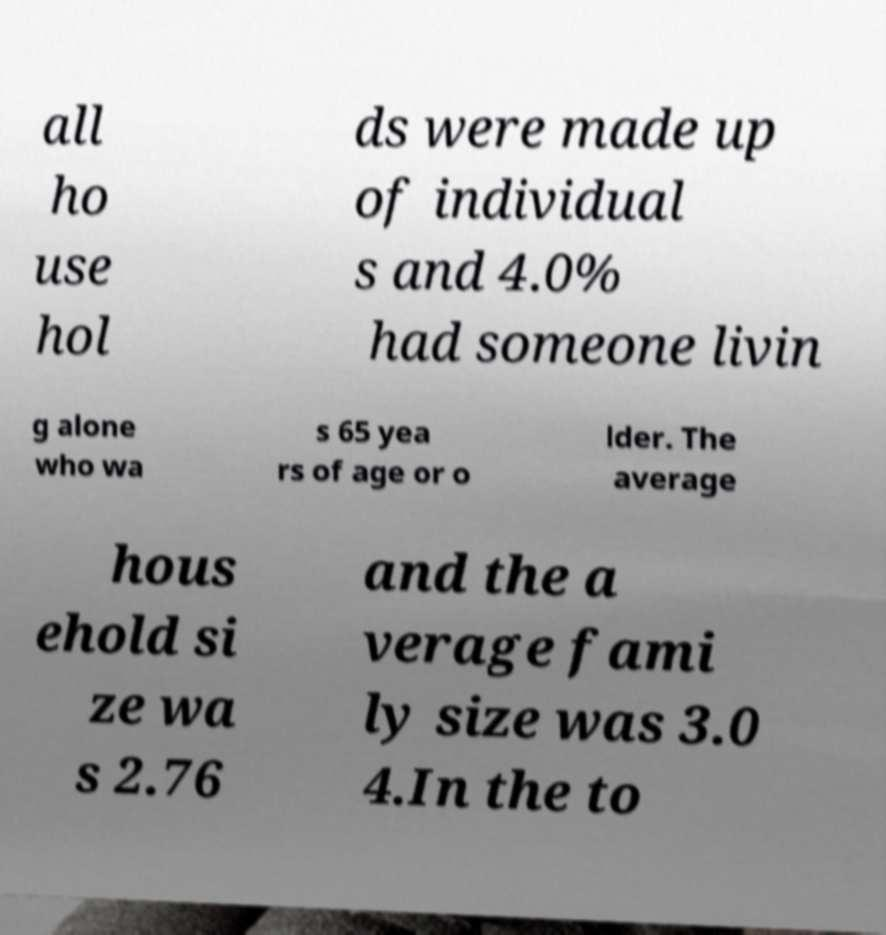I need the written content from this picture converted into text. Can you do that? all ho use hol ds were made up of individual s and 4.0% had someone livin g alone who wa s 65 yea rs of age or o lder. The average hous ehold si ze wa s 2.76 and the a verage fami ly size was 3.0 4.In the to 